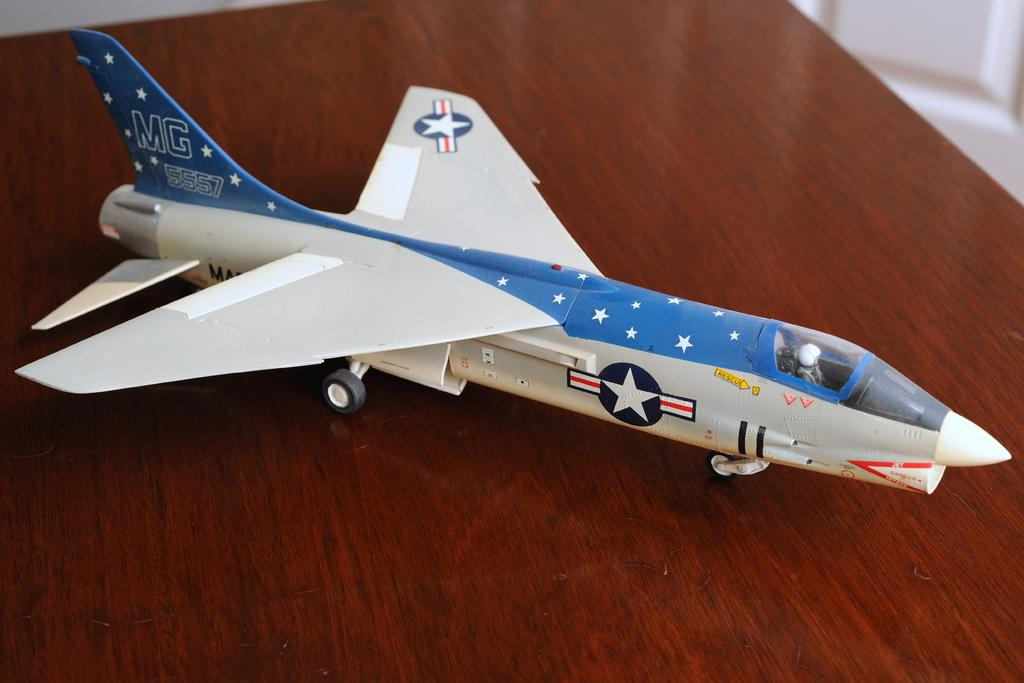What is the main subject of the image? The main subject of the image is a toy aeroplane. Where is the toy aeroplane located in the image? The toy aeroplane is in the center of the image. On what surface is the toy aeroplane placed? The toy aeroplane is placed on a table. How many brothers are playing with the toy aeroplane in the image? There are no brothers present in the image; it only features a toy aeroplane on a table. What type of toothbrush is used to clean the toy aeroplane in the image? There is no toothbrush present in the image, and the toy aeroplane does not require cleaning. 